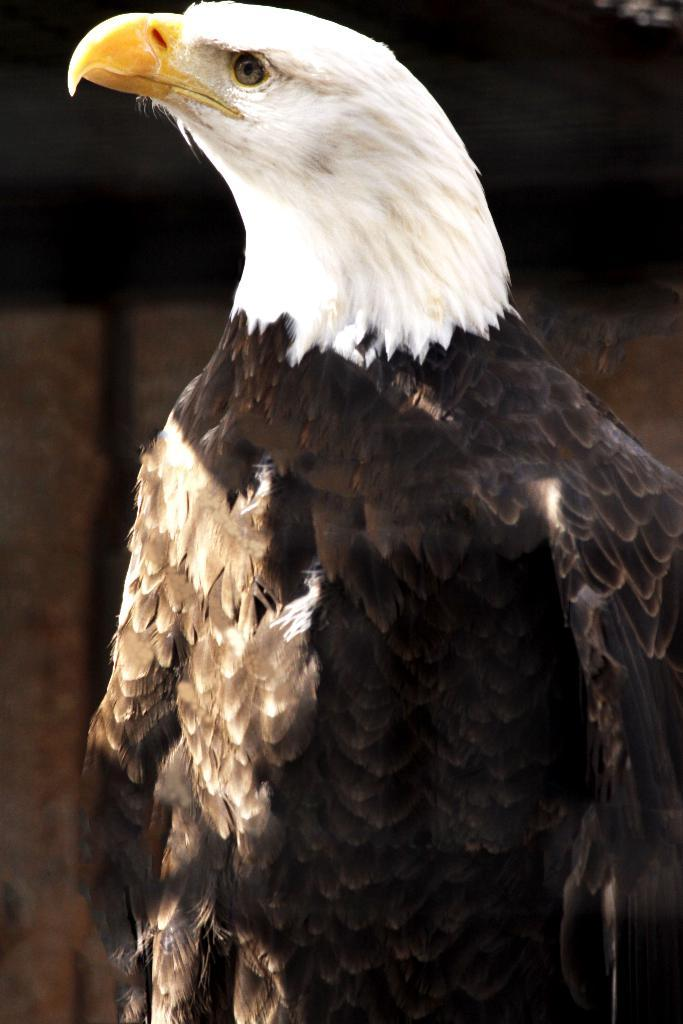What is the main subject of the image? There is an eagle in the center of the image. What color is the eagle in the image? The eagle is in black and white color. Can you describe the background of the image? The background of the image is dark. How many balloons are being offered by the eagle in the image? There are no balloons present in the image. The image only features an eagle in black and white color, with a dark background. 